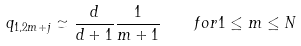<formula> <loc_0><loc_0><loc_500><loc_500>q _ { 1 , 2 m + j } \simeq \frac { d } { d + 1 } \frac { 1 } { m + 1 } \quad f o r 1 \leq m \leq N</formula> 